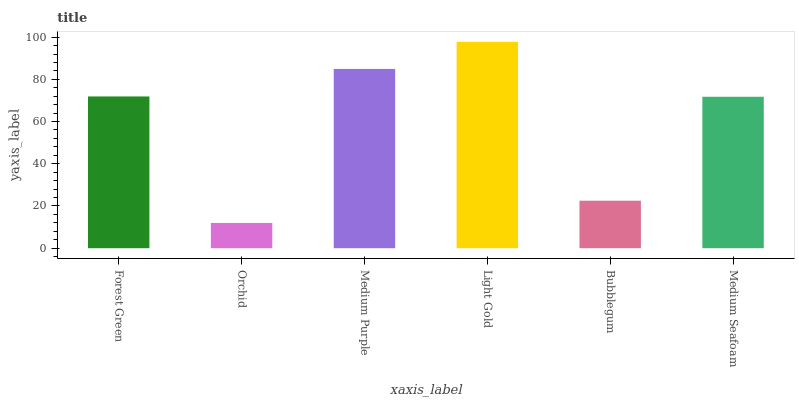Is Medium Purple the minimum?
Answer yes or no. No. Is Medium Purple the maximum?
Answer yes or no. No. Is Medium Purple greater than Orchid?
Answer yes or no. Yes. Is Orchid less than Medium Purple?
Answer yes or no. Yes. Is Orchid greater than Medium Purple?
Answer yes or no. No. Is Medium Purple less than Orchid?
Answer yes or no. No. Is Forest Green the high median?
Answer yes or no. Yes. Is Medium Seafoam the low median?
Answer yes or no. Yes. Is Medium Seafoam the high median?
Answer yes or no. No. Is Light Gold the low median?
Answer yes or no. No. 